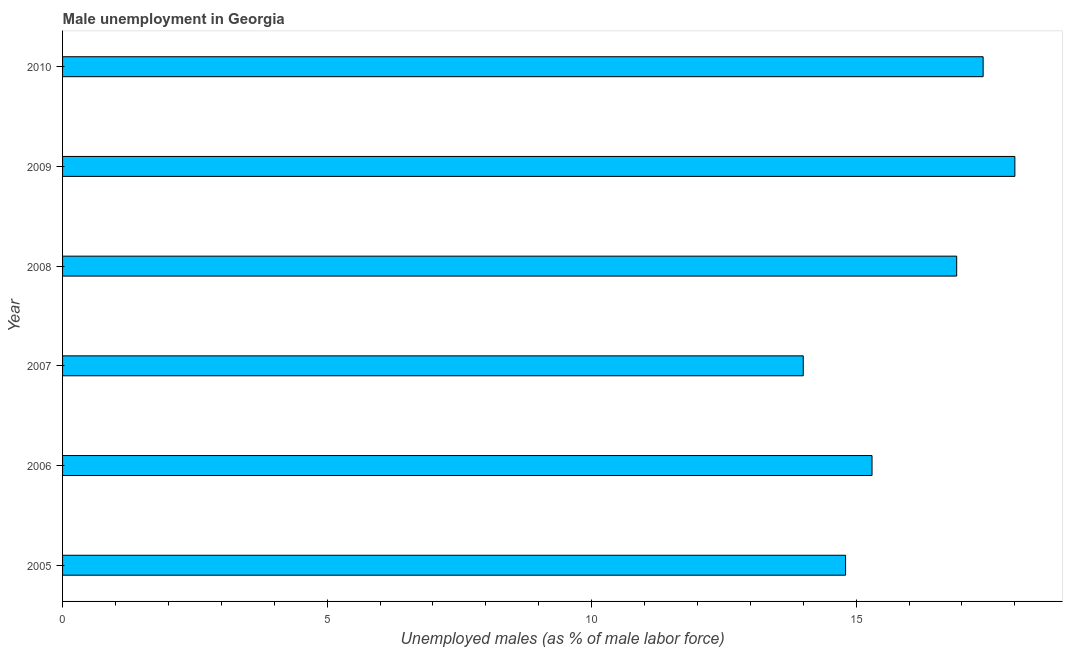Does the graph contain grids?
Your response must be concise. No. What is the title of the graph?
Provide a succinct answer. Male unemployment in Georgia. What is the label or title of the X-axis?
Your response must be concise. Unemployed males (as % of male labor force). What is the label or title of the Y-axis?
Your answer should be compact. Year. What is the unemployed males population in 2006?
Give a very brief answer. 15.3. In which year was the unemployed males population maximum?
Provide a short and direct response. 2009. In which year was the unemployed males population minimum?
Provide a succinct answer. 2007. What is the sum of the unemployed males population?
Provide a short and direct response. 96.4. What is the average unemployed males population per year?
Your answer should be very brief. 16.07. What is the median unemployed males population?
Offer a terse response. 16.1. What is the ratio of the unemployed males population in 2005 to that in 2006?
Give a very brief answer. 0.97. Is the unemployed males population in 2005 less than that in 2010?
Offer a very short reply. Yes. What is the difference between the highest and the second highest unemployed males population?
Ensure brevity in your answer.  0.6. What is the difference between the highest and the lowest unemployed males population?
Provide a succinct answer. 4. In how many years, is the unemployed males population greater than the average unemployed males population taken over all years?
Ensure brevity in your answer.  3. How many bars are there?
Give a very brief answer. 6. Are all the bars in the graph horizontal?
Make the answer very short. Yes. Are the values on the major ticks of X-axis written in scientific E-notation?
Your answer should be compact. No. What is the Unemployed males (as % of male labor force) in 2005?
Keep it short and to the point. 14.8. What is the Unemployed males (as % of male labor force) of 2006?
Make the answer very short. 15.3. What is the Unemployed males (as % of male labor force) of 2007?
Offer a very short reply. 14. What is the Unemployed males (as % of male labor force) in 2008?
Your answer should be very brief. 16.9. What is the Unemployed males (as % of male labor force) in 2010?
Your response must be concise. 17.4. What is the difference between the Unemployed males (as % of male labor force) in 2005 and 2006?
Provide a succinct answer. -0.5. What is the difference between the Unemployed males (as % of male labor force) in 2005 and 2008?
Provide a short and direct response. -2.1. What is the difference between the Unemployed males (as % of male labor force) in 2005 and 2010?
Give a very brief answer. -2.6. What is the difference between the Unemployed males (as % of male labor force) in 2006 and 2008?
Ensure brevity in your answer.  -1.6. What is the difference between the Unemployed males (as % of male labor force) in 2006 and 2009?
Make the answer very short. -2.7. What is the difference between the Unemployed males (as % of male labor force) in 2007 and 2008?
Ensure brevity in your answer.  -2.9. What is the difference between the Unemployed males (as % of male labor force) in 2007 and 2010?
Offer a very short reply. -3.4. What is the difference between the Unemployed males (as % of male labor force) in 2008 and 2009?
Your response must be concise. -1.1. What is the difference between the Unemployed males (as % of male labor force) in 2008 and 2010?
Your answer should be compact. -0.5. What is the ratio of the Unemployed males (as % of male labor force) in 2005 to that in 2006?
Ensure brevity in your answer.  0.97. What is the ratio of the Unemployed males (as % of male labor force) in 2005 to that in 2007?
Give a very brief answer. 1.06. What is the ratio of the Unemployed males (as % of male labor force) in 2005 to that in 2008?
Make the answer very short. 0.88. What is the ratio of the Unemployed males (as % of male labor force) in 2005 to that in 2009?
Your answer should be very brief. 0.82. What is the ratio of the Unemployed males (as % of male labor force) in 2005 to that in 2010?
Offer a terse response. 0.85. What is the ratio of the Unemployed males (as % of male labor force) in 2006 to that in 2007?
Your response must be concise. 1.09. What is the ratio of the Unemployed males (as % of male labor force) in 2006 to that in 2008?
Your answer should be very brief. 0.91. What is the ratio of the Unemployed males (as % of male labor force) in 2006 to that in 2009?
Offer a terse response. 0.85. What is the ratio of the Unemployed males (as % of male labor force) in 2006 to that in 2010?
Your response must be concise. 0.88. What is the ratio of the Unemployed males (as % of male labor force) in 2007 to that in 2008?
Provide a short and direct response. 0.83. What is the ratio of the Unemployed males (as % of male labor force) in 2007 to that in 2009?
Offer a very short reply. 0.78. What is the ratio of the Unemployed males (as % of male labor force) in 2007 to that in 2010?
Provide a succinct answer. 0.81. What is the ratio of the Unemployed males (as % of male labor force) in 2008 to that in 2009?
Give a very brief answer. 0.94. What is the ratio of the Unemployed males (as % of male labor force) in 2009 to that in 2010?
Keep it short and to the point. 1.03. 